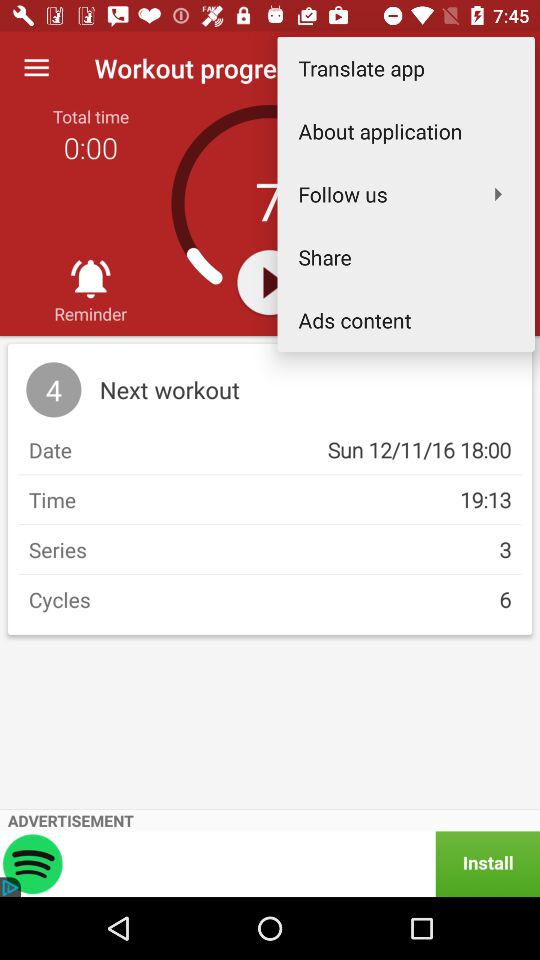What's the Total Time? The total time is 0:00. 